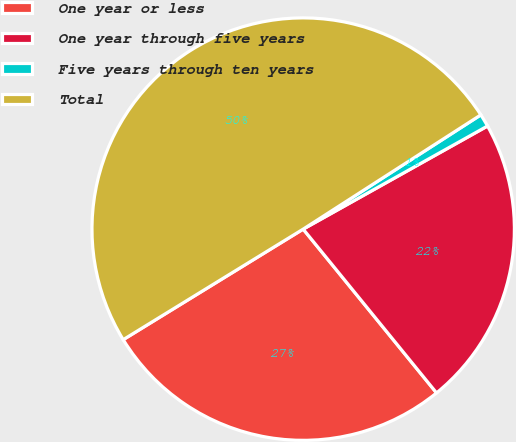Convert chart to OTSL. <chart><loc_0><loc_0><loc_500><loc_500><pie_chart><fcel>One year or less<fcel>One year through five years<fcel>Five years through ten years<fcel>Total<nl><fcel>27.11%<fcel>22.24%<fcel>0.98%<fcel>49.67%<nl></chart> 